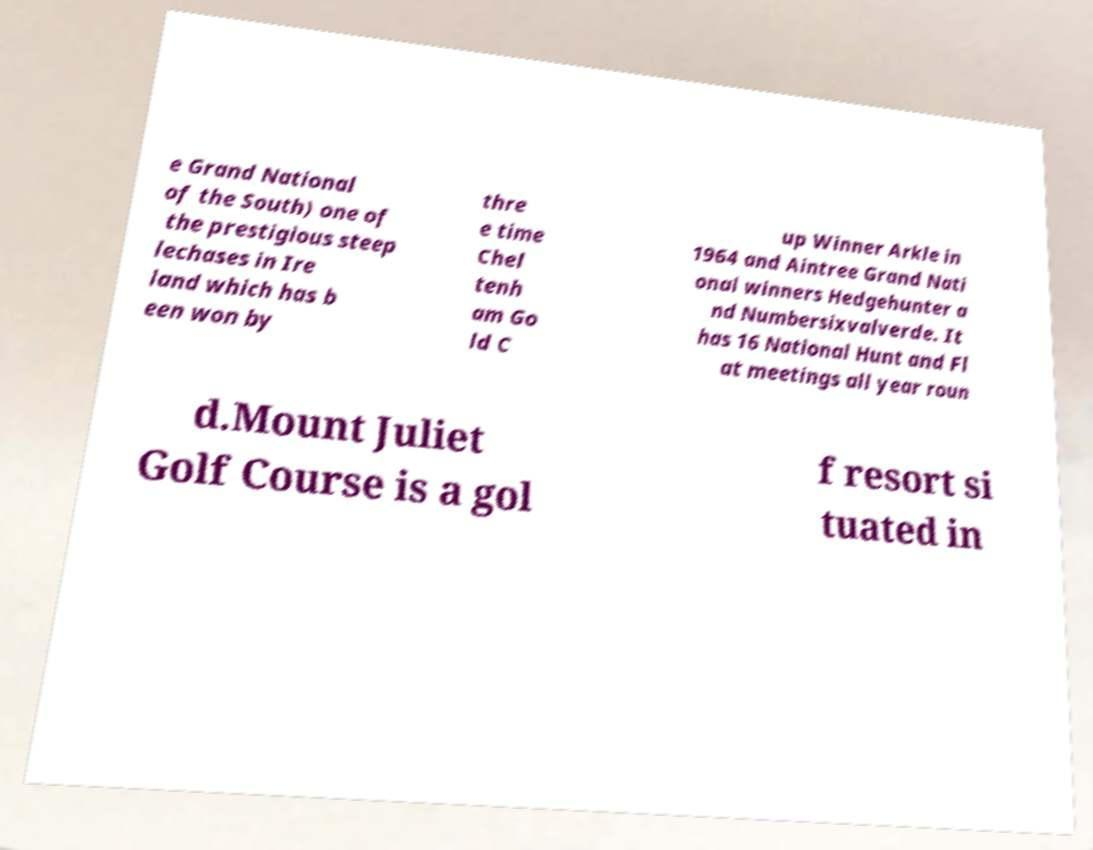Can you accurately transcribe the text from the provided image for me? e Grand National of the South) one of the prestigious steep lechases in Ire land which has b een won by thre e time Chel tenh am Go ld C up Winner Arkle in 1964 and Aintree Grand Nati onal winners Hedgehunter a nd Numbersixvalverde. It has 16 National Hunt and Fl at meetings all year roun d.Mount Juliet Golf Course is a gol f resort si tuated in 